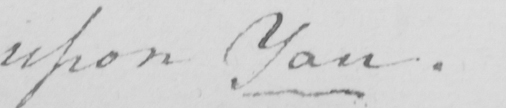What text is written in this handwritten line? upon You . 